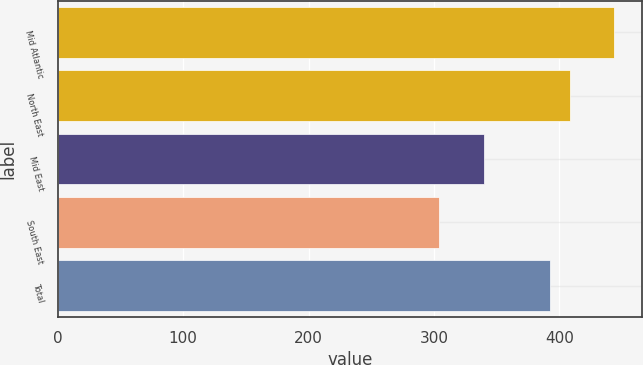Convert chart to OTSL. <chart><loc_0><loc_0><loc_500><loc_500><bar_chart><fcel>Mid Atlantic<fcel>North East<fcel>Mid East<fcel>South East<fcel>Total<nl><fcel>443.4<fcel>408.7<fcel>340.1<fcel>304.1<fcel>392.8<nl></chart> 